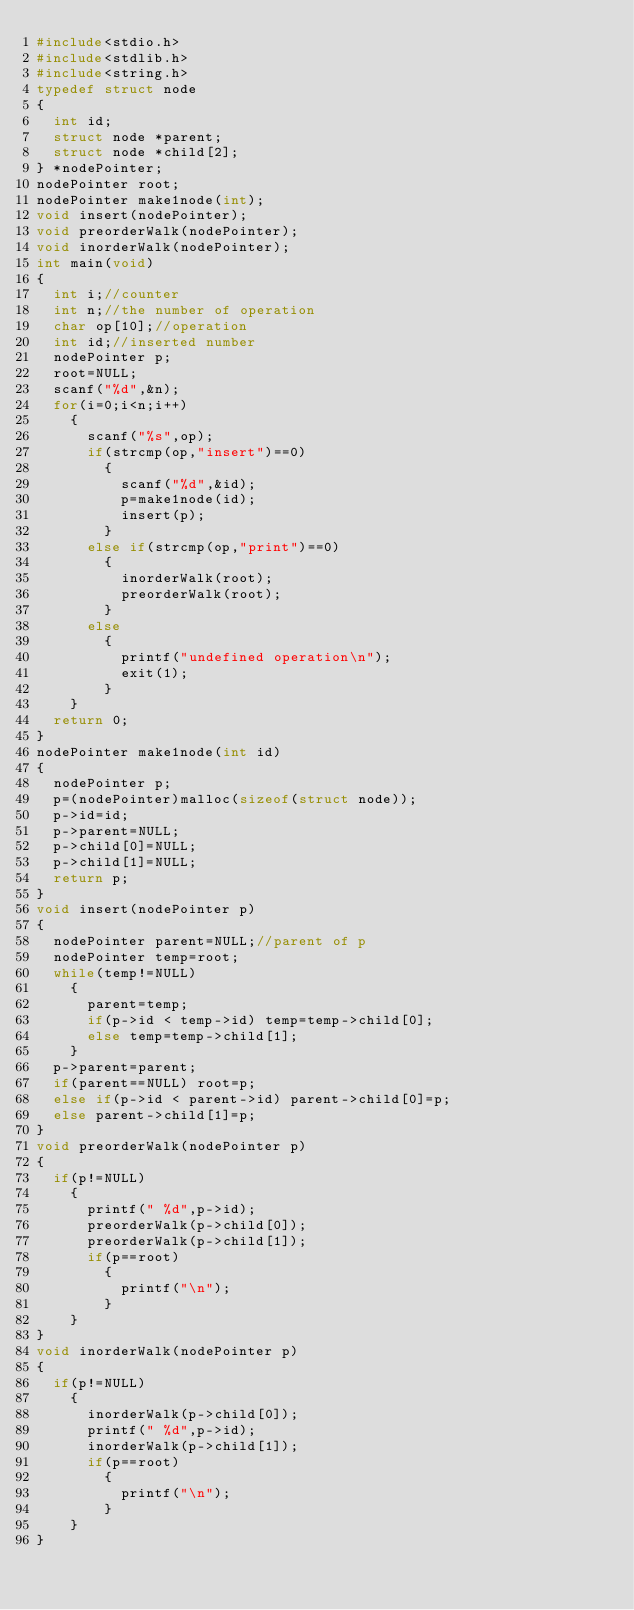<code> <loc_0><loc_0><loc_500><loc_500><_C_>#include<stdio.h>
#include<stdlib.h>
#include<string.h>
typedef struct node
{
  int id;
  struct node *parent;
  struct node *child[2];
} *nodePointer;
nodePointer root;
nodePointer make1node(int);
void insert(nodePointer);
void preorderWalk(nodePointer);
void inorderWalk(nodePointer);
int main(void)
{
  int i;//counter
  int n;//the number of operation
  char op[10];//operation
  int id;//inserted number
  nodePointer p;
  root=NULL;
  scanf("%d",&n);
  for(i=0;i<n;i++)
    {
      scanf("%s",op);
      if(strcmp(op,"insert")==0)
        {
          scanf("%d",&id);
          p=make1node(id);
          insert(p);
        }
      else if(strcmp(op,"print")==0)
        {
          inorderWalk(root);
          preorderWalk(root);
        }
      else
        {
          printf("undefined operation\n");
          exit(1);
        }
    }
  return 0;
}
nodePointer make1node(int id)
{
  nodePointer p;
  p=(nodePointer)malloc(sizeof(struct node));
  p->id=id;
  p->parent=NULL;
  p->child[0]=NULL;
  p->child[1]=NULL;
  return p;
}
void insert(nodePointer p)
{
  nodePointer parent=NULL;//parent of p
  nodePointer temp=root;
  while(temp!=NULL)
    {
      parent=temp;
      if(p->id < temp->id) temp=temp->child[0];
      else temp=temp->child[1];
    }
  p->parent=parent;
  if(parent==NULL) root=p;
  else if(p->id < parent->id) parent->child[0]=p;
  else parent->child[1]=p;
}
void preorderWalk(nodePointer p)
{
  if(p!=NULL)
    {
      printf(" %d",p->id);
      preorderWalk(p->child[0]);
      preorderWalk(p->child[1]);
      if(p==root)
        {
          printf("\n");
        }
    }
}
void inorderWalk(nodePointer p)
{
  if(p!=NULL)
    {
      inorderWalk(p->child[0]);
      printf(" %d",p->id);
      inorderWalk(p->child[1]);
      if(p==root)
        {
          printf("\n");
        }
    }
}

</code> 